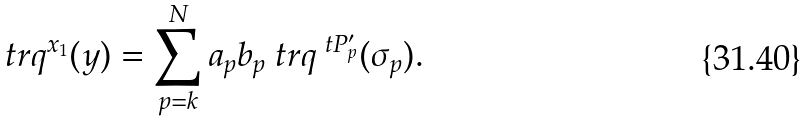Convert formula to latex. <formula><loc_0><loc_0><loc_500><loc_500>\ t r q ^ { x _ { 1 } } ( y ) = \sum _ { p = k } ^ { N } a _ { p } b _ { p } \ t r q ^ { \ t P ^ { \prime } _ { p } } ( \sigma _ { p } ) .</formula> 